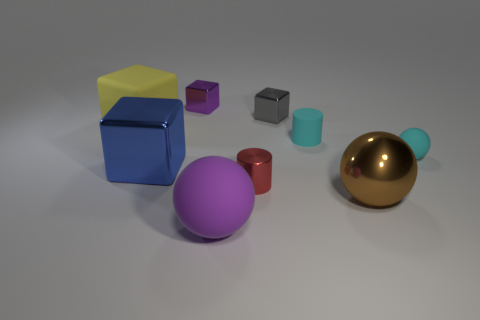Are the big ball on the right side of the purple matte sphere and the sphere that is in front of the large brown metal thing made of the same material?
Your response must be concise. No. Are there more small metal blocks on the right side of the red cylinder than tiny red metallic things on the right side of the tiny cyan rubber ball?
Offer a very short reply. Yes. The big metallic cube is what color?
Your answer should be compact. Blue. What is the color of the rubber object that is both behind the tiny rubber ball and to the right of the yellow thing?
Provide a short and direct response. Cyan. There is a matte sphere right of the small object that is in front of the rubber sphere that is behind the big brown sphere; what color is it?
Provide a succinct answer. Cyan. What color is the matte sphere that is the same size as the brown metallic sphere?
Keep it short and to the point. Purple. What shape is the rubber thing that is to the left of the large matte object in front of the big object that is behind the small cyan cylinder?
Give a very brief answer. Cube. The rubber object that is the same color as the rubber cylinder is what shape?
Keep it short and to the point. Sphere. How many things are tiny rubber balls or tiny metal objects on the left side of the large matte sphere?
Give a very brief answer. 2. Do the cylinder that is on the left side of the gray block and the purple rubber sphere have the same size?
Your answer should be compact. No. 